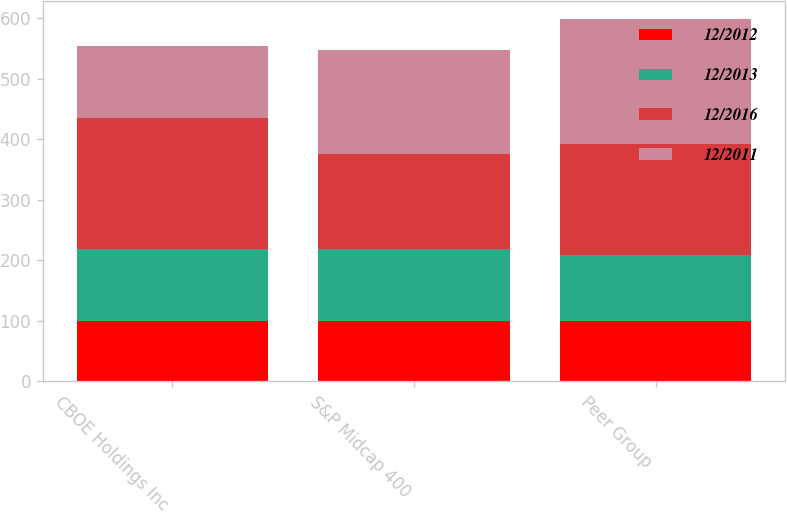Convert chart to OTSL. <chart><loc_0><loc_0><loc_500><loc_500><stacked_bar_chart><ecel><fcel>CBOE Holdings Inc<fcel>S&P Midcap 400<fcel>Peer Group<nl><fcel>12/2012<fcel>100<fcel>100<fcel>100<nl><fcel>12/2013<fcel>119.1<fcel>117.88<fcel>108.45<nl><fcel>12/2016<fcel>215.3<fcel>157.37<fcel>184.46<nl><fcel>12/2011<fcel>119.1<fcel>172.74<fcel>205.09<nl></chart> 